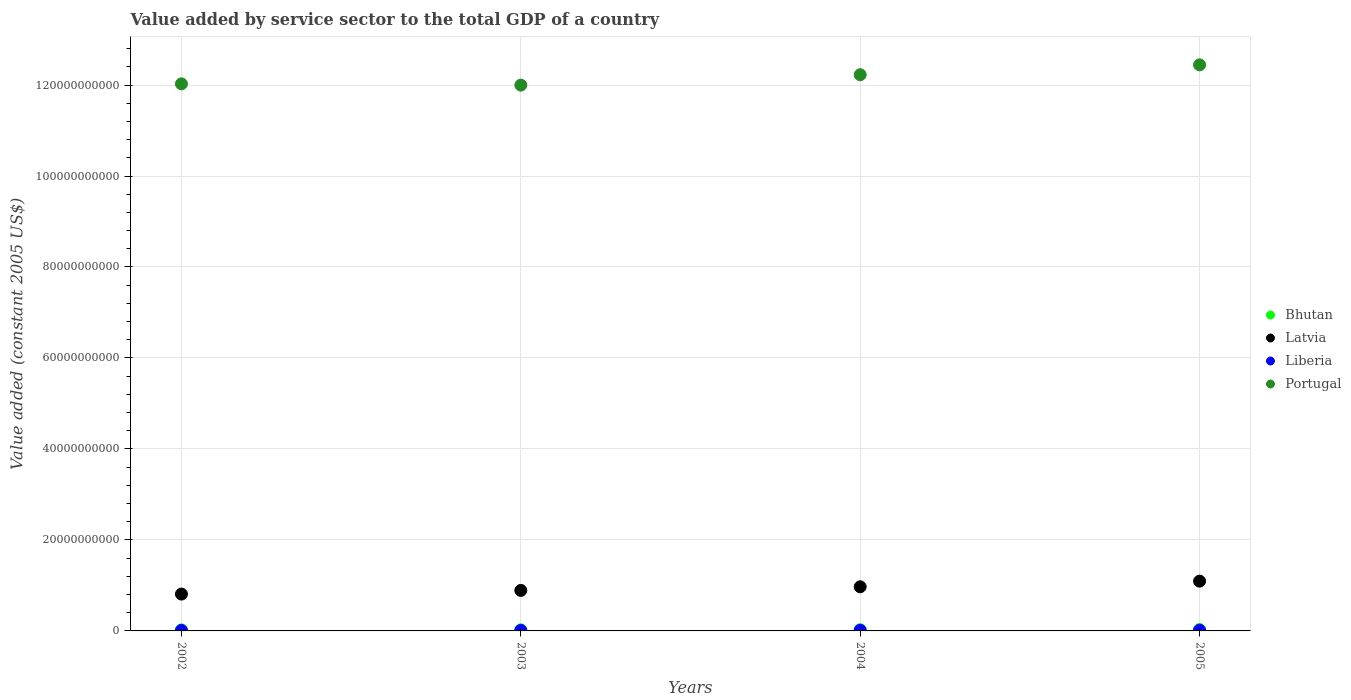How many different coloured dotlines are there?
Your response must be concise. 4. Is the number of dotlines equal to the number of legend labels?
Your answer should be compact. Yes. What is the value added by service sector in Portugal in 2002?
Give a very brief answer. 1.20e+11. Across all years, what is the maximum value added by service sector in Bhutan?
Provide a short and direct response. 3.12e+08. Across all years, what is the minimum value added by service sector in Liberia?
Ensure brevity in your answer.  1.11e+08. What is the total value added by service sector in Bhutan in the graph?
Make the answer very short. 1.05e+09. What is the difference between the value added by service sector in Latvia in 2002 and that in 2003?
Keep it short and to the point. -8.04e+08. What is the difference between the value added by service sector in Bhutan in 2002 and the value added by service sector in Portugal in 2003?
Your answer should be compact. -1.20e+11. What is the average value added by service sector in Portugal per year?
Your answer should be compact. 1.22e+11. In the year 2004, what is the difference between the value added by service sector in Latvia and value added by service sector in Portugal?
Ensure brevity in your answer.  -1.13e+11. In how many years, is the value added by service sector in Bhutan greater than 76000000000 US$?
Your answer should be compact. 0. What is the ratio of the value added by service sector in Bhutan in 2004 to that in 2005?
Provide a succinct answer. 0.87. Is the difference between the value added by service sector in Latvia in 2002 and 2005 greater than the difference between the value added by service sector in Portugal in 2002 and 2005?
Your answer should be very brief. Yes. What is the difference between the highest and the second highest value added by service sector in Portugal?
Offer a terse response. 2.17e+09. What is the difference between the highest and the lowest value added by service sector in Bhutan?
Provide a succinct answer. 8.77e+07. In how many years, is the value added by service sector in Portugal greater than the average value added by service sector in Portugal taken over all years?
Keep it short and to the point. 2. Is the sum of the value added by service sector in Liberia in 2002 and 2005 greater than the maximum value added by service sector in Bhutan across all years?
Offer a terse response. No. Is it the case that in every year, the sum of the value added by service sector in Liberia and value added by service sector in Latvia  is greater than the value added by service sector in Bhutan?
Make the answer very short. Yes. Does the value added by service sector in Liberia monotonically increase over the years?
Provide a short and direct response. No. Is the value added by service sector in Liberia strictly greater than the value added by service sector in Portugal over the years?
Offer a very short reply. No. How many years are there in the graph?
Offer a terse response. 4. What is the difference between two consecutive major ticks on the Y-axis?
Keep it short and to the point. 2.00e+1. Are the values on the major ticks of Y-axis written in scientific E-notation?
Make the answer very short. No. Does the graph contain grids?
Give a very brief answer. Yes. Where does the legend appear in the graph?
Your response must be concise. Center right. How many legend labels are there?
Provide a short and direct response. 4. What is the title of the graph?
Offer a very short reply. Value added by service sector to the total GDP of a country. Does "Greenland" appear as one of the legend labels in the graph?
Offer a terse response. No. What is the label or title of the X-axis?
Offer a very short reply. Years. What is the label or title of the Y-axis?
Provide a short and direct response. Value added (constant 2005 US$). What is the Value added (constant 2005 US$) of Bhutan in 2002?
Give a very brief answer. 2.24e+08. What is the Value added (constant 2005 US$) in Latvia in 2002?
Provide a short and direct response. 8.10e+09. What is the Value added (constant 2005 US$) of Liberia in 2002?
Provide a succinct answer. 1.13e+08. What is the Value added (constant 2005 US$) of Portugal in 2002?
Offer a very short reply. 1.20e+11. What is the Value added (constant 2005 US$) in Bhutan in 2003?
Keep it short and to the point. 2.45e+08. What is the Value added (constant 2005 US$) of Latvia in 2003?
Provide a short and direct response. 8.90e+09. What is the Value added (constant 2005 US$) of Liberia in 2003?
Provide a short and direct response. 1.11e+08. What is the Value added (constant 2005 US$) of Portugal in 2003?
Provide a succinct answer. 1.20e+11. What is the Value added (constant 2005 US$) of Bhutan in 2004?
Provide a succinct answer. 2.72e+08. What is the Value added (constant 2005 US$) of Latvia in 2004?
Keep it short and to the point. 9.70e+09. What is the Value added (constant 2005 US$) in Liberia in 2004?
Offer a terse response. 1.35e+08. What is the Value added (constant 2005 US$) of Portugal in 2004?
Provide a short and direct response. 1.22e+11. What is the Value added (constant 2005 US$) of Bhutan in 2005?
Your answer should be very brief. 3.12e+08. What is the Value added (constant 2005 US$) of Latvia in 2005?
Offer a very short reply. 1.09e+1. What is the Value added (constant 2005 US$) of Liberia in 2005?
Give a very brief answer. 1.47e+08. What is the Value added (constant 2005 US$) of Portugal in 2005?
Provide a short and direct response. 1.24e+11. Across all years, what is the maximum Value added (constant 2005 US$) of Bhutan?
Provide a succinct answer. 3.12e+08. Across all years, what is the maximum Value added (constant 2005 US$) of Latvia?
Your response must be concise. 1.09e+1. Across all years, what is the maximum Value added (constant 2005 US$) of Liberia?
Your answer should be compact. 1.47e+08. Across all years, what is the maximum Value added (constant 2005 US$) of Portugal?
Your answer should be compact. 1.24e+11. Across all years, what is the minimum Value added (constant 2005 US$) of Bhutan?
Ensure brevity in your answer.  2.24e+08. Across all years, what is the minimum Value added (constant 2005 US$) in Latvia?
Ensure brevity in your answer.  8.10e+09. Across all years, what is the minimum Value added (constant 2005 US$) of Liberia?
Your response must be concise. 1.11e+08. Across all years, what is the minimum Value added (constant 2005 US$) in Portugal?
Your response must be concise. 1.20e+11. What is the total Value added (constant 2005 US$) of Bhutan in the graph?
Your response must be concise. 1.05e+09. What is the total Value added (constant 2005 US$) in Latvia in the graph?
Provide a short and direct response. 3.76e+1. What is the total Value added (constant 2005 US$) of Liberia in the graph?
Provide a short and direct response. 5.07e+08. What is the total Value added (constant 2005 US$) of Portugal in the graph?
Keep it short and to the point. 4.87e+11. What is the difference between the Value added (constant 2005 US$) of Bhutan in 2002 and that in 2003?
Provide a succinct answer. -2.10e+07. What is the difference between the Value added (constant 2005 US$) of Latvia in 2002 and that in 2003?
Make the answer very short. -8.04e+08. What is the difference between the Value added (constant 2005 US$) in Liberia in 2002 and that in 2003?
Offer a very short reply. 1.74e+06. What is the difference between the Value added (constant 2005 US$) of Portugal in 2002 and that in 2003?
Your answer should be compact. 2.81e+08. What is the difference between the Value added (constant 2005 US$) in Bhutan in 2002 and that in 2004?
Offer a terse response. -4.75e+07. What is the difference between the Value added (constant 2005 US$) of Latvia in 2002 and that in 2004?
Offer a very short reply. -1.60e+09. What is the difference between the Value added (constant 2005 US$) in Liberia in 2002 and that in 2004?
Offer a very short reply. -2.21e+07. What is the difference between the Value added (constant 2005 US$) of Portugal in 2002 and that in 2004?
Provide a succinct answer. -2.00e+09. What is the difference between the Value added (constant 2005 US$) of Bhutan in 2002 and that in 2005?
Make the answer very short. -8.77e+07. What is the difference between the Value added (constant 2005 US$) in Latvia in 2002 and that in 2005?
Your answer should be compact. -2.84e+09. What is the difference between the Value added (constant 2005 US$) of Liberia in 2002 and that in 2005?
Your answer should be compact. -3.39e+07. What is the difference between the Value added (constant 2005 US$) of Portugal in 2002 and that in 2005?
Keep it short and to the point. -4.18e+09. What is the difference between the Value added (constant 2005 US$) of Bhutan in 2003 and that in 2004?
Give a very brief answer. -2.65e+07. What is the difference between the Value added (constant 2005 US$) in Latvia in 2003 and that in 2004?
Make the answer very short. -7.98e+08. What is the difference between the Value added (constant 2005 US$) of Liberia in 2003 and that in 2004?
Offer a terse response. -2.39e+07. What is the difference between the Value added (constant 2005 US$) of Portugal in 2003 and that in 2004?
Your answer should be compact. -2.29e+09. What is the difference between the Value added (constant 2005 US$) in Bhutan in 2003 and that in 2005?
Make the answer very short. -6.67e+07. What is the difference between the Value added (constant 2005 US$) in Latvia in 2003 and that in 2005?
Give a very brief answer. -2.04e+09. What is the difference between the Value added (constant 2005 US$) of Liberia in 2003 and that in 2005?
Offer a terse response. -3.57e+07. What is the difference between the Value added (constant 2005 US$) of Portugal in 2003 and that in 2005?
Make the answer very short. -4.46e+09. What is the difference between the Value added (constant 2005 US$) of Bhutan in 2004 and that in 2005?
Provide a succinct answer. -4.02e+07. What is the difference between the Value added (constant 2005 US$) in Latvia in 2004 and that in 2005?
Ensure brevity in your answer.  -1.24e+09. What is the difference between the Value added (constant 2005 US$) of Liberia in 2004 and that in 2005?
Make the answer very short. -1.18e+07. What is the difference between the Value added (constant 2005 US$) of Portugal in 2004 and that in 2005?
Provide a succinct answer. -2.17e+09. What is the difference between the Value added (constant 2005 US$) in Bhutan in 2002 and the Value added (constant 2005 US$) in Latvia in 2003?
Your response must be concise. -8.68e+09. What is the difference between the Value added (constant 2005 US$) in Bhutan in 2002 and the Value added (constant 2005 US$) in Liberia in 2003?
Provide a short and direct response. 1.13e+08. What is the difference between the Value added (constant 2005 US$) of Bhutan in 2002 and the Value added (constant 2005 US$) of Portugal in 2003?
Keep it short and to the point. -1.20e+11. What is the difference between the Value added (constant 2005 US$) of Latvia in 2002 and the Value added (constant 2005 US$) of Liberia in 2003?
Your answer should be compact. 7.99e+09. What is the difference between the Value added (constant 2005 US$) of Latvia in 2002 and the Value added (constant 2005 US$) of Portugal in 2003?
Offer a very short reply. -1.12e+11. What is the difference between the Value added (constant 2005 US$) of Liberia in 2002 and the Value added (constant 2005 US$) of Portugal in 2003?
Keep it short and to the point. -1.20e+11. What is the difference between the Value added (constant 2005 US$) in Bhutan in 2002 and the Value added (constant 2005 US$) in Latvia in 2004?
Your response must be concise. -9.48e+09. What is the difference between the Value added (constant 2005 US$) in Bhutan in 2002 and the Value added (constant 2005 US$) in Liberia in 2004?
Make the answer very short. 8.90e+07. What is the difference between the Value added (constant 2005 US$) in Bhutan in 2002 and the Value added (constant 2005 US$) in Portugal in 2004?
Provide a succinct answer. -1.22e+11. What is the difference between the Value added (constant 2005 US$) of Latvia in 2002 and the Value added (constant 2005 US$) of Liberia in 2004?
Offer a terse response. 7.96e+09. What is the difference between the Value added (constant 2005 US$) in Latvia in 2002 and the Value added (constant 2005 US$) in Portugal in 2004?
Offer a very short reply. -1.14e+11. What is the difference between the Value added (constant 2005 US$) in Liberia in 2002 and the Value added (constant 2005 US$) in Portugal in 2004?
Your response must be concise. -1.22e+11. What is the difference between the Value added (constant 2005 US$) of Bhutan in 2002 and the Value added (constant 2005 US$) of Latvia in 2005?
Give a very brief answer. -1.07e+1. What is the difference between the Value added (constant 2005 US$) of Bhutan in 2002 and the Value added (constant 2005 US$) of Liberia in 2005?
Offer a terse response. 7.72e+07. What is the difference between the Value added (constant 2005 US$) of Bhutan in 2002 and the Value added (constant 2005 US$) of Portugal in 2005?
Give a very brief answer. -1.24e+11. What is the difference between the Value added (constant 2005 US$) in Latvia in 2002 and the Value added (constant 2005 US$) in Liberia in 2005?
Make the answer very short. 7.95e+09. What is the difference between the Value added (constant 2005 US$) in Latvia in 2002 and the Value added (constant 2005 US$) in Portugal in 2005?
Your answer should be very brief. -1.16e+11. What is the difference between the Value added (constant 2005 US$) of Liberia in 2002 and the Value added (constant 2005 US$) of Portugal in 2005?
Your answer should be very brief. -1.24e+11. What is the difference between the Value added (constant 2005 US$) in Bhutan in 2003 and the Value added (constant 2005 US$) in Latvia in 2004?
Your answer should be compact. -9.46e+09. What is the difference between the Value added (constant 2005 US$) in Bhutan in 2003 and the Value added (constant 2005 US$) in Liberia in 2004?
Give a very brief answer. 1.10e+08. What is the difference between the Value added (constant 2005 US$) of Bhutan in 2003 and the Value added (constant 2005 US$) of Portugal in 2004?
Ensure brevity in your answer.  -1.22e+11. What is the difference between the Value added (constant 2005 US$) in Latvia in 2003 and the Value added (constant 2005 US$) in Liberia in 2004?
Your answer should be very brief. 8.77e+09. What is the difference between the Value added (constant 2005 US$) of Latvia in 2003 and the Value added (constant 2005 US$) of Portugal in 2004?
Offer a very short reply. -1.13e+11. What is the difference between the Value added (constant 2005 US$) in Liberia in 2003 and the Value added (constant 2005 US$) in Portugal in 2004?
Provide a succinct answer. -1.22e+11. What is the difference between the Value added (constant 2005 US$) in Bhutan in 2003 and the Value added (constant 2005 US$) in Latvia in 2005?
Your answer should be compact. -1.07e+1. What is the difference between the Value added (constant 2005 US$) in Bhutan in 2003 and the Value added (constant 2005 US$) in Liberia in 2005?
Provide a short and direct response. 9.82e+07. What is the difference between the Value added (constant 2005 US$) in Bhutan in 2003 and the Value added (constant 2005 US$) in Portugal in 2005?
Make the answer very short. -1.24e+11. What is the difference between the Value added (constant 2005 US$) in Latvia in 2003 and the Value added (constant 2005 US$) in Liberia in 2005?
Ensure brevity in your answer.  8.76e+09. What is the difference between the Value added (constant 2005 US$) in Latvia in 2003 and the Value added (constant 2005 US$) in Portugal in 2005?
Ensure brevity in your answer.  -1.16e+11. What is the difference between the Value added (constant 2005 US$) in Liberia in 2003 and the Value added (constant 2005 US$) in Portugal in 2005?
Ensure brevity in your answer.  -1.24e+11. What is the difference between the Value added (constant 2005 US$) in Bhutan in 2004 and the Value added (constant 2005 US$) in Latvia in 2005?
Provide a short and direct response. -1.07e+1. What is the difference between the Value added (constant 2005 US$) in Bhutan in 2004 and the Value added (constant 2005 US$) in Liberia in 2005?
Your answer should be compact. 1.25e+08. What is the difference between the Value added (constant 2005 US$) of Bhutan in 2004 and the Value added (constant 2005 US$) of Portugal in 2005?
Provide a succinct answer. -1.24e+11. What is the difference between the Value added (constant 2005 US$) of Latvia in 2004 and the Value added (constant 2005 US$) of Liberia in 2005?
Offer a terse response. 9.56e+09. What is the difference between the Value added (constant 2005 US$) in Latvia in 2004 and the Value added (constant 2005 US$) in Portugal in 2005?
Provide a short and direct response. -1.15e+11. What is the difference between the Value added (constant 2005 US$) in Liberia in 2004 and the Value added (constant 2005 US$) in Portugal in 2005?
Offer a very short reply. -1.24e+11. What is the average Value added (constant 2005 US$) in Bhutan per year?
Your response must be concise. 2.63e+08. What is the average Value added (constant 2005 US$) in Latvia per year?
Keep it short and to the point. 9.41e+09. What is the average Value added (constant 2005 US$) in Liberia per year?
Make the answer very short. 1.27e+08. What is the average Value added (constant 2005 US$) of Portugal per year?
Your answer should be very brief. 1.22e+11. In the year 2002, what is the difference between the Value added (constant 2005 US$) of Bhutan and Value added (constant 2005 US$) of Latvia?
Offer a very short reply. -7.88e+09. In the year 2002, what is the difference between the Value added (constant 2005 US$) of Bhutan and Value added (constant 2005 US$) of Liberia?
Offer a very short reply. 1.11e+08. In the year 2002, what is the difference between the Value added (constant 2005 US$) in Bhutan and Value added (constant 2005 US$) in Portugal?
Keep it short and to the point. -1.20e+11. In the year 2002, what is the difference between the Value added (constant 2005 US$) in Latvia and Value added (constant 2005 US$) in Liberia?
Offer a very short reply. 7.99e+09. In the year 2002, what is the difference between the Value added (constant 2005 US$) in Latvia and Value added (constant 2005 US$) in Portugal?
Make the answer very short. -1.12e+11. In the year 2002, what is the difference between the Value added (constant 2005 US$) of Liberia and Value added (constant 2005 US$) of Portugal?
Provide a short and direct response. -1.20e+11. In the year 2003, what is the difference between the Value added (constant 2005 US$) in Bhutan and Value added (constant 2005 US$) in Latvia?
Your answer should be very brief. -8.66e+09. In the year 2003, what is the difference between the Value added (constant 2005 US$) of Bhutan and Value added (constant 2005 US$) of Liberia?
Ensure brevity in your answer.  1.34e+08. In the year 2003, what is the difference between the Value added (constant 2005 US$) in Bhutan and Value added (constant 2005 US$) in Portugal?
Provide a short and direct response. -1.20e+11. In the year 2003, what is the difference between the Value added (constant 2005 US$) in Latvia and Value added (constant 2005 US$) in Liberia?
Keep it short and to the point. 8.79e+09. In the year 2003, what is the difference between the Value added (constant 2005 US$) of Latvia and Value added (constant 2005 US$) of Portugal?
Offer a terse response. -1.11e+11. In the year 2003, what is the difference between the Value added (constant 2005 US$) of Liberia and Value added (constant 2005 US$) of Portugal?
Ensure brevity in your answer.  -1.20e+11. In the year 2004, what is the difference between the Value added (constant 2005 US$) in Bhutan and Value added (constant 2005 US$) in Latvia?
Provide a succinct answer. -9.43e+09. In the year 2004, what is the difference between the Value added (constant 2005 US$) in Bhutan and Value added (constant 2005 US$) in Liberia?
Your answer should be compact. 1.36e+08. In the year 2004, what is the difference between the Value added (constant 2005 US$) in Bhutan and Value added (constant 2005 US$) in Portugal?
Ensure brevity in your answer.  -1.22e+11. In the year 2004, what is the difference between the Value added (constant 2005 US$) of Latvia and Value added (constant 2005 US$) of Liberia?
Ensure brevity in your answer.  9.57e+09. In the year 2004, what is the difference between the Value added (constant 2005 US$) of Latvia and Value added (constant 2005 US$) of Portugal?
Your answer should be compact. -1.13e+11. In the year 2004, what is the difference between the Value added (constant 2005 US$) of Liberia and Value added (constant 2005 US$) of Portugal?
Provide a succinct answer. -1.22e+11. In the year 2005, what is the difference between the Value added (constant 2005 US$) in Bhutan and Value added (constant 2005 US$) in Latvia?
Provide a short and direct response. -1.06e+1. In the year 2005, what is the difference between the Value added (constant 2005 US$) in Bhutan and Value added (constant 2005 US$) in Liberia?
Ensure brevity in your answer.  1.65e+08. In the year 2005, what is the difference between the Value added (constant 2005 US$) of Bhutan and Value added (constant 2005 US$) of Portugal?
Make the answer very short. -1.24e+11. In the year 2005, what is the difference between the Value added (constant 2005 US$) in Latvia and Value added (constant 2005 US$) in Liberia?
Provide a short and direct response. 1.08e+1. In the year 2005, what is the difference between the Value added (constant 2005 US$) in Latvia and Value added (constant 2005 US$) in Portugal?
Keep it short and to the point. -1.13e+11. In the year 2005, what is the difference between the Value added (constant 2005 US$) in Liberia and Value added (constant 2005 US$) in Portugal?
Make the answer very short. -1.24e+11. What is the ratio of the Value added (constant 2005 US$) of Bhutan in 2002 to that in 2003?
Make the answer very short. 0.91. What is the ratio of the Value added (constant 2005 US$) of Latvia in 2002 to that in 2003?
Give a very brief answer. 0.91. What is the ratio of the Value added (constant 2005 US$) in Liberia in 2002 to that in 2003?
Make the answer very short. 1.02. What is the ratio of the Value added (constant 2005 US$) in Portugal in 2002 to that in 2003?
Make the answer very short. 1. What is the ratio of the Value added (constant 2005 US$) of Bhutan in 2002 to that in 2004?
Make the answer very short. 0.83. What is the ratio of the Value added (constant 2005 US$) of Latvia in 2002 to that in 2004?
Provide a short and direct response. 0.83. What is the ratio of the Value added (constant 2005 US$) in Liberia in 2002 to that in 2004?
Offer a very short reply. 0.84. What is the ratio of the Value added (constant 2005 US$) of Portugal in 2002 to that in 2004?
Make the answer very short. 0.98. What is the ratio of the Value added (constant 2005 US$) in Bhutan in 2002 to that in 2005?
Offer a very short reply. 0.72. What is the ratio of the Value added (constant 2005 US$) of Latvia in 2002 to that in 2005?
Ensure brevity in your answer.  0.74. What is the ratio of the Value added (constant 2005 US$) of Liberia in 2002 to that in 2005?
Offer a very short reply. 0.77. What is the ratio of the Value added (constant 2005 US$) of Portugal in 2002 to that in 2005?
Ensure brevity in your answer.  0.97. What is the ratio of the Value added (constant 2005 US$) in Bhutan in 2003 to that in 2004?
Provide a short and direct response. 0.9. What is the ratio of the Value added (constant 2005 US$) in Latvia in 2003 to that in 2004?
Your answer should be compact. 0.92. What is the ratio of the Value added (constant 2005 US$) of Liberia in 2003 to that in 2004?
Give a very brief answer. 0.82. What is the ratio of the Value added (constant 2005 US$) in Portugal in 2003 to that in 2004?
Your answer should be very brief. 0.98. What is the ratio of the Value added (constant 2005 US$) in Bhutan in 2003 to that in 2005?
Your response must be concise. 0.79. What is the ratio of the Value added (constant 2005 US$) in Latvia in 2003 to that in 2005?
Your answer should be very brief. 0.81. What is the ratio of the Value added (constant 2005 US$) in Liberia in 2003 to that in 2005?
Give a very brief answer. 0.76. What is the ratio of the Value added (constant 2005 US$) in Portugal in 2003 to that in 2005?
Provide a short and direct response. 0.96. What is the ratio of the Value added (constant 2005 US$) in Bhutan in 2004 to that in 2005?
Ensure brevity in your answer.  0.87. What is the ratio of the Value added (constant 2005 US$) in Latvia in 2004 to that in 2005?
Your response must be concise. 0.89. What is the ratio of the Value added (constant 2005 US$) of Liberia in 2004 to that in 2005?
Your answer should be very brief. 0.92. What is the ratio of the Value added (constant 2005 US$) in Portugal in 2004 to that in 2005?
Keep it short and to the point. 0.98. What is the difference between the highest and the second highest Value added (constant 2005 US$) of Bhutan?
Ensure brevity in your answer.  4.02e+07. What is the difference between the highest and the second highest Value added (constant 2005 US$) of Latvia?
Make the answer very short. 1.24e+09. What is the difference between the highest and the second highest Value added (constant 2005 US$) in Liberia?
Offer a terse response. 1.18e+07. What is the difference between the highest and the second highest Value added (constant 2005 US$) in Portugal?
Give a very brief answer. 2.17e+09. What is the difference between the highest and the lowest Value added (constant 2005 US$) in Bhutan?
Your answer should be compact. 8.77e+07. What is the difference between the highest and the lowest Value added (constant 2005 US$) of Latvia?
Provide a short and direct response. 2.84e+09. What is the difference between the highest and the lowest Value added (constant 2005 US$) in Liberia?
Your answer should be compact. 3.57e+07. What is the difference between the highest and the lowest Value added (constant 2005 US$) in Portugal?
Your answer should be very brief. 4.46e+09. 